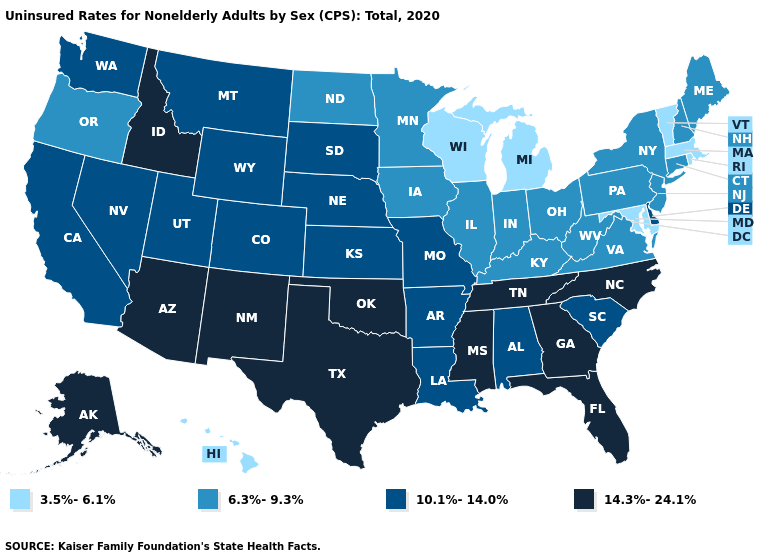Name the states that have a value in the range 14.3%-24.1%?
Answer briefly. Alaska, Arizona, Florida, Georgia, Idaho, Mississippi, New Mexico, North Carolina, Oklahoma, Tennessee, Texas. Name the states that have a value in the range 3.5%-6.1%?
Keep it brief. Hawaii, Maryland, Massachusetts, Michigan, Rhode Island, Vermont, Wisconsin. What is the value of Minnesota?
Write a very short answer. 6.3%-9.3%. Which states have the highest value in the USA?
Be succinct. Alaska, Arizona, Florida, Georgia, Idaho, Mississippi, New Mexico, North Carolina, Oklahoma, Tennessee, Texas. What is the lowest value in the USA?
Short answer required. 3.5%-6.1%. Does the map have missing data?
Answer briefly. No. Name the states that have a value in the range 14.3%-24.1%?
Write a very short answer. Alaska, Arizona, Florida, Georgia, Idaho, Mississippi, New Mexico, North Carolina, Oklahoma, Tennessee, Texas. What is the lowest value in the Northeast?
Write a very short answer. 3.5%-6.1%. Name the states that have a value in the range 10.1%-14.0%?
Give a very brief answer. Alabama, Arkansas, California, Colorado, Delaware, Kansas, Louisiana, Missouri, Montana, Nebraska, Nevada, South Carolina, South Dakota, Utah, Washington, Wyoming. Does Tennessee have the lowest value in the South?
Concise answer only. No. How many symbols are there in the legend?
Give a very brief answer. 4. What is the value of California?
Be succinct. 10.1%-14.0%. Is the legend a continuous bar?
Be succinct. No. Name the states that have a value in the range 3.5%-6.1%?
Write a very short answer. Hawaii, Maryland, Massachusetts, Michigan, Rhode Island, Vermont, Wisconsin. Which states have the highest value in the USA?
Concise answer only. Alaska, Arizona, Florida, Georgia, Idaho, Mississippi, New Mexico, North Carolina, Oklahoma, Tennessee, Texas. 